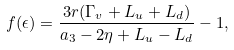<formula> <loc_0><loc_0><loc_500><loc_500>f ( \epsilon ) = \frac { 3 r ( \Gamma _ { v } + L _ { u } + L _ { d } ) } { a _ { 3 } - 2 \eta + L _ { u } - L _ { d } } - 1 ,</formula> 